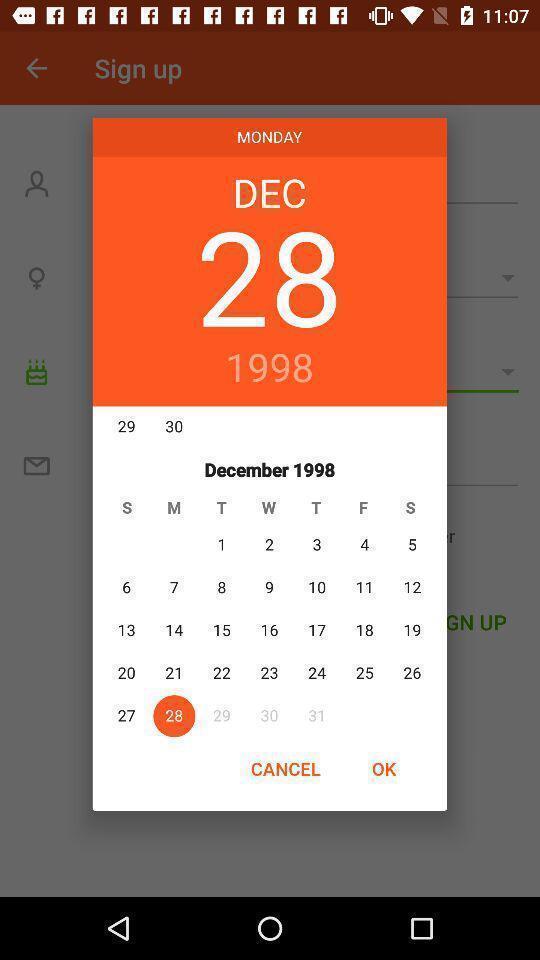Describe this image in words. Pop-up with date choosing option in a dating app. 